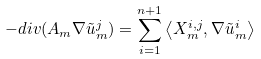Convert formula to latex. <formula><loc_0><loc_0><loc_500><loc_500>- d i v ( A _ { m } \nabla \tilde { u } _ { m } ^ { j } ) = \sum _ { i = 1 } ^ { n + 1 } \left \langle X _ { m } ^ { i , j } , \nabla \tilde { u } _ { m } ^ { i } \right \rangle</formula> 